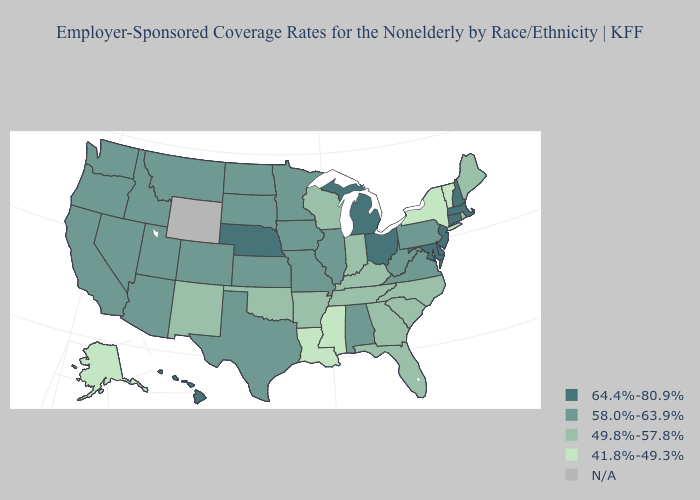What is the value of Maine?
Be succinct. 49.8%-57.8%. Does California have the lowest value in the West?
Short answer required. No. Name the states that have a value in the range 58.0%-63.9%?
Keep it brief. Alabama, Arizona, California, Colorado, Idaho, Illinois, Iowa, Kansas, Minnesota, Missouri, Montana, Nevada, North Dakota, Oregon, Pennsylvania, South Dakota, Texas, Utah, Virginia, Washington, West Virginia. Name the states that have a value in the range 41.8%-49.3%?
Short answer required. Alaska, Louisiana, Mississippi, New York, Vermont. What is the lowest value in the USA?
Answer briefly. 41.8%-49.3%. Name the states that have a value in the range 64.4%-80.9%?
Be succinct. Connecticut, Delaware, Hawaii, Maryland, Massachusetts, Michigan, Nebraska, New Hampshire, New Jersey, Ohio. What is the lowest value in the West?
Be succinct. 41.8%-49.3%. Name the states that have a value in the range 58.0%-63.9%?
Answer briefly. Alabama, Arizona, California, Colorado, Idaho, Illinois, Iowa, Kansas, Minnesota, Missouri, Montana, Nevada, North Dakota, Oregon, Pennsylvania, South Dakota, Texas, Utah, Virginia, Washington, West Virginia. What is the lowest value in the West?
Keep it brief. 41.8%-49.3%. Name the states that have a value in the range 58.0%-63.9%?
Concise answer only. Alabama, Arizona, California, Colorado, Idaho, Illinois, Iowa, Kansas, Minnesota, Missouri, Montana, Nevada, North Dakota, Oregon, Pennsylvania, South Dakota, Texas, Utah, Virginia, Washington, West Virginia. What is the value of West Virginia?
Answer briefly. 58.0%-63.9%. What is the highest value in the West ?
Concise answer only. 64.4%-80.9%. Name the states that have a value in the range 58.0%-63.9%?
Concise answer only. Alabama, Arizona, California, Colorado, Idaho, Illinois, Iowa, Kansas, Minnesota, Missouri, Montana, Nevada, North Dakota, Oregon, Pennsylvania, South Dakota, Texas, Utah, Virginia, Washington, West Virginia. Which states have the lowest value in the South?
Short answer required. Louisiana, Mississippi. 